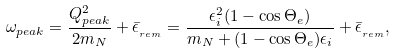<formula> <loc_0><loc_0><loc_500><loc_500>\omega _ { p e a k } = \frac { Q ^ { 2 } _ { p e a k } } { 2 m _ { N } } + \bar { \epsilon } _ { _ { r e m } } = \frac { \epsilon _ { i } ^ { 2 } ( 1 - \cos \Theta _ { e } ) } { m _ { N } + ( 1 - \cos \Theta _ { e } ) \epsilon _ { i } } + \bar { \epsilon } _ { _ { r e m } } ,</formula> 